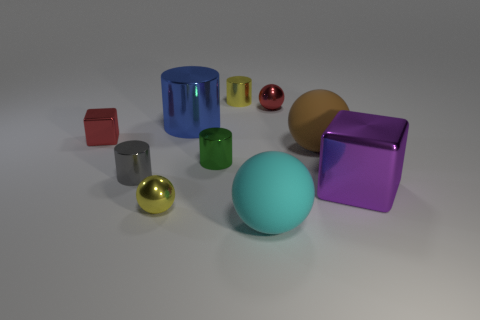What number of tiny things are either matte spheres or yellow cylinders?
Ensure brevity in your answer.  1. Is there a rubber cube of the same size as the brown object?
Your answer should be compact. No. What color is the small sphere to the left of the small yellow thing behind the big metal thing to the right of the large blue cylinder?
Your answer should be very brief. Yellow. Are the red cube and the large sphere that is behind the gray object made of the same material?
Make the answer very short. No. What size is the green thing that is the same shape as the blue metallic object?
Ensure brevity in your answer.  Small. Are there the same number of metal balls that are in front of the brown ball and small yellow spheres that are left of the big shiny block?
Ensure brevity in your answer.  Yes. What number of other things are there of the same material as the purple thing
Your answer should be very brief. 7. Is the number of purple things to the left of the brown object the same as the number of large cubes?
Give a very brief answer. No. There is a brown matte sphere; is its size the same as the cube behind the large brown matte ball?
Offer a very short reply. No. There is a large shiny thing that is to the right of the tiny green metallic thing; what is its shape?
Give a very brief answer. Cube. 